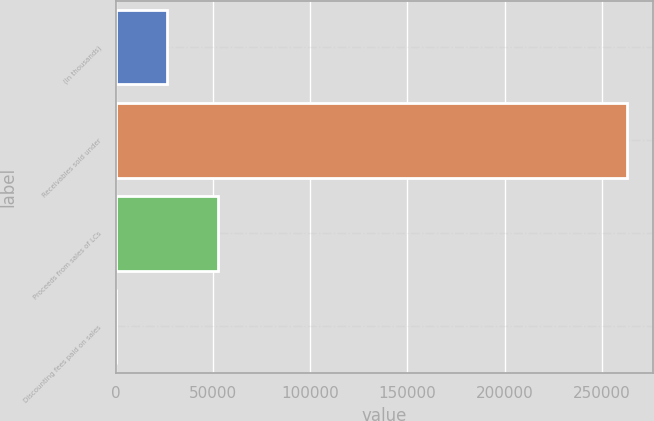Convert chart. <chart><loc_0><loc_0><loc_500><loc_500><bar_chart><fcel>(In thousands)<fcel>Receivables sold under<fcel>Proceeds from sales of LCs<fcel>Discounting fees paid on sales<nl><fcel>26430.3<fcel>262998<fcel>52715.6<fcel>145<nl></chart> 